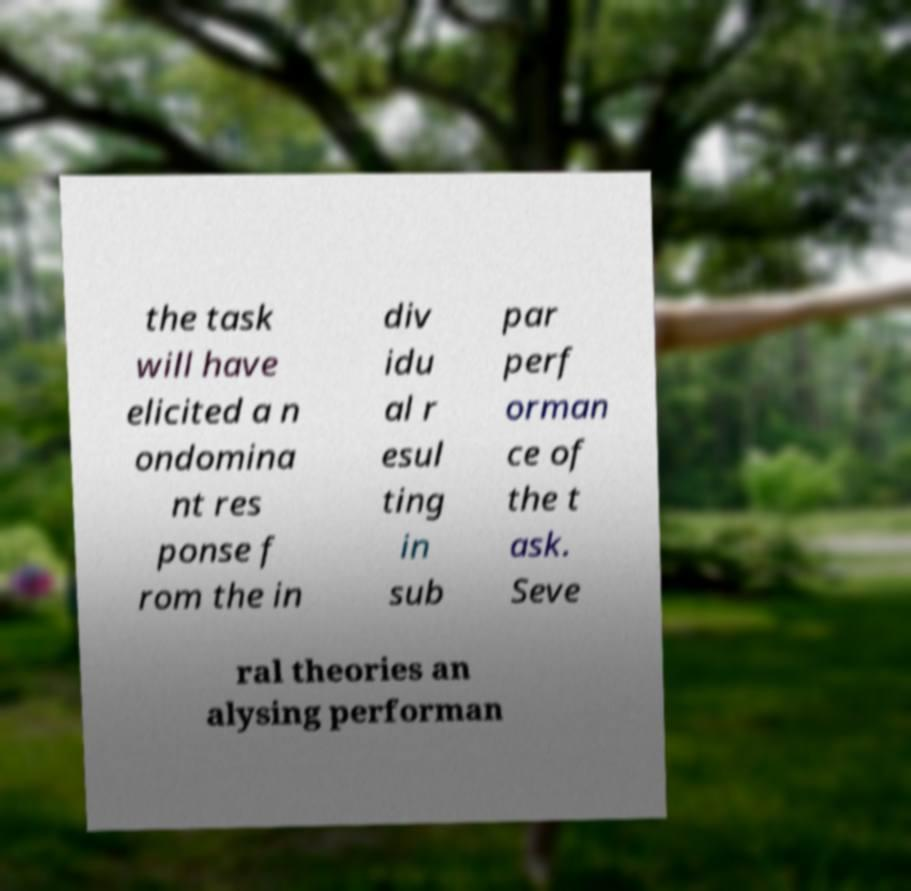Can you accurately transcribe the text from the provided image for me? the task will have elicited a n ondomina nt res ponse f rom the in div idu al r esul ting in sub par perf orman ce of the t ask. Seve ral theories an alysing performan 